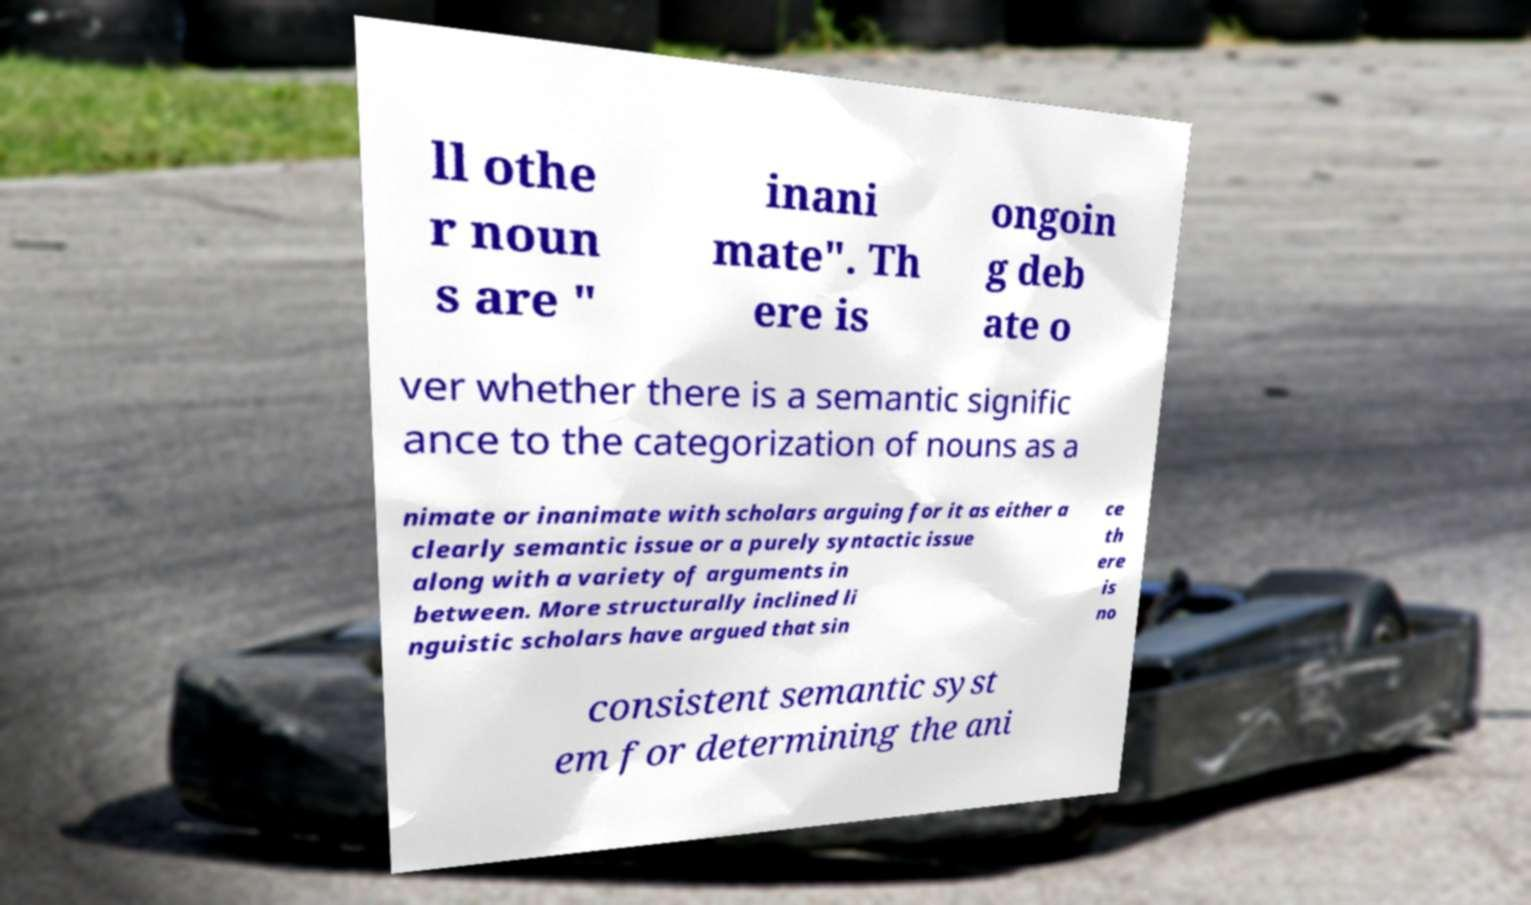Could you assist in decoding the text presented in this image and type it out clearly? ll othe r noun s are " inani mate". Th ere is ongoin g deb ate o ver whether there is a semantic signific ance to the categorization of nouns as a nimate or inanimate with scholars arguing for it as either a clearly semantic issue or a purely syntactic issue along with a variety of arguments in between. More structurally inclined li nguistic scholars have argued that sin ce th ere is no consistent semantic syst em for determining the ani 